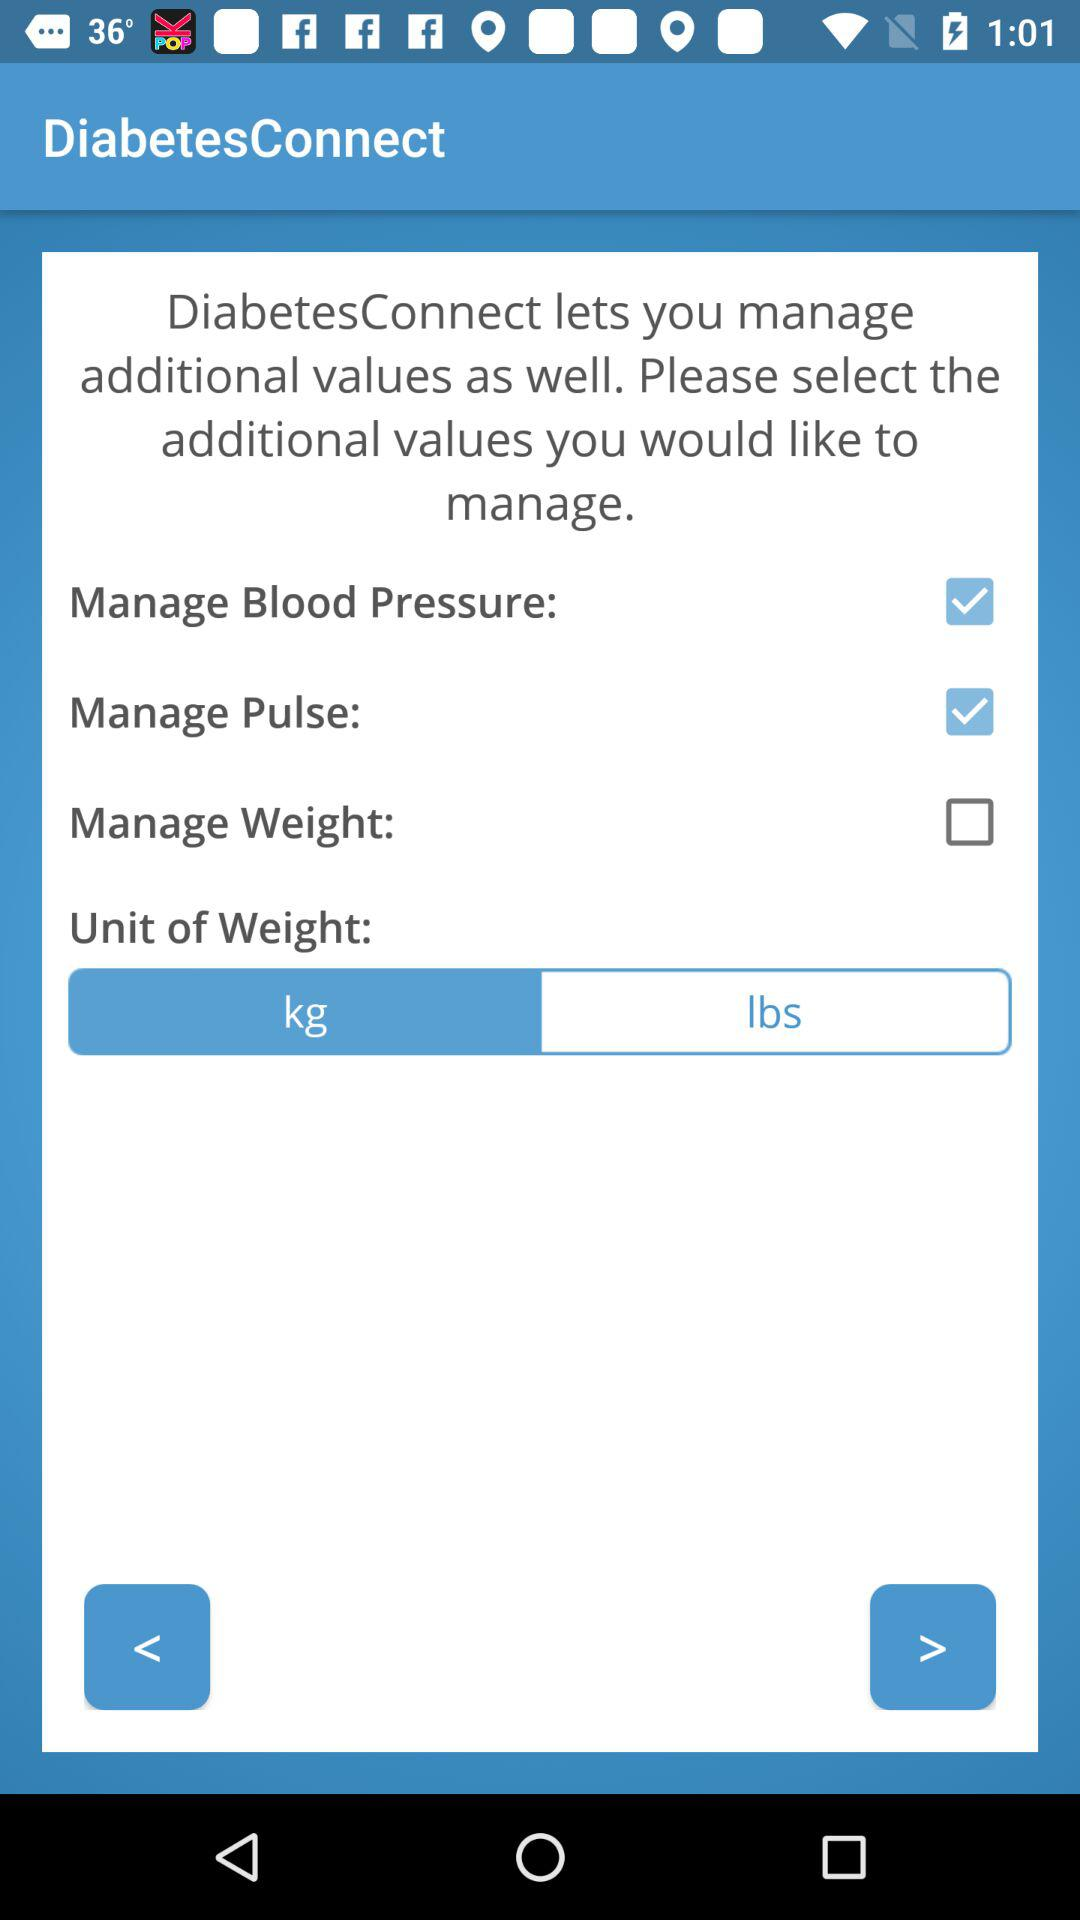Which options are selected? The selected options are "Manage Blood Pressure" and "Manage Pulse". 